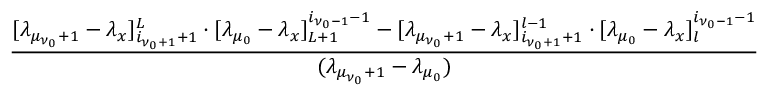<formula> <loc_0><loc_0><loc_500><loc_500>\frac { [ \lambda _ { \mu _ { \nu _ { 0 } } + 1 } - \lambda _ { x } ] _ { i _ { \nu _ { 0 } + 1 } + 1 } ^ { L } \cdot [ \lambda _ { \mu _ { 0 } } - \lambda _ { x } ] _ { L + 1 } ^ { i _ { \nu _ { 0 } - 1 } - 1 } - [ \lambda _ { \mu _ { \nu _ { 0 } } + 1 } - \lambda _ { x } ] _ { i _ { \nu _ { 0 } + 1 } + 1 } ^ { l - 1 } \cdot [ \lambda _ { \mu _ { 0 } } - \lambda _ { x } ] _ { l } ^ { i _ { \nu _ { 0 } - 1 } - 1 } } { ( \lambda _ { \mu _ { \nu _ { 0 } } + 1 } - \lambda _ { \mu _ { 0 } } ) }</formula> 